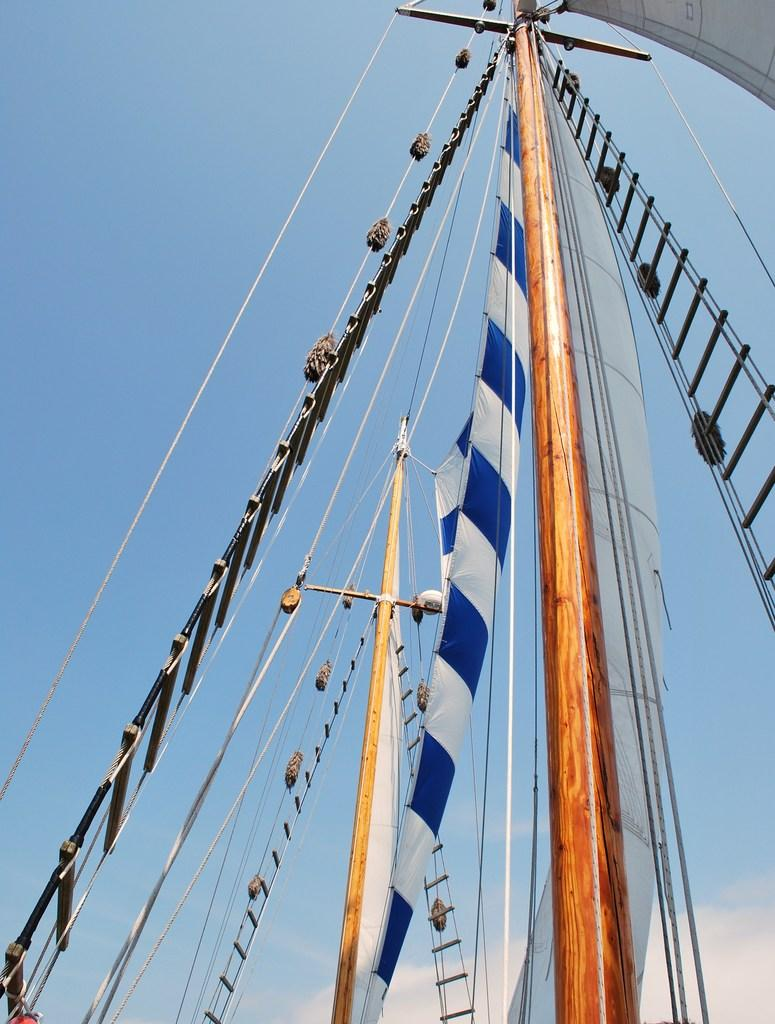What is the main subject of the image? The main subject of the image is a part of a ship. What other objects can be seen in the image? There is a pole, a ladder, cloth, and some ropes attached to the pole. What is the condition of the sky in the image? The sky is visible at the top of the image. What type of pen is being used by the fireman in the image? There is no fireman or pen present in the image. What is the surprise element in the image? There is no surprise element in the image; it depicts a part of a ship and related objects. 